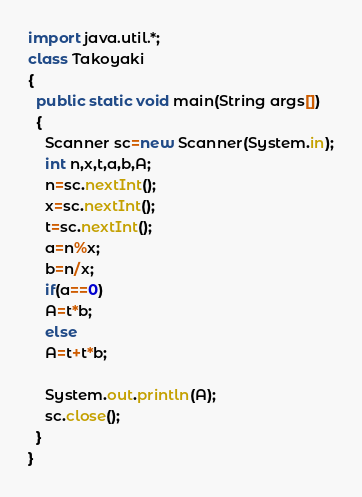Convert code to text. <code><loc_0><loc_0><loc_500><loc_500><_Java_>import java.util.*;
class Takoyaki
{
  public static void main(String args[])
  {
    Scanner sc=new Scanner(System.in);
    int n,x,t,a,b,A;
    n=sc.nextInt();
    x=sc.nextInt();
    t=sc.nextInt();
    a=n%x;
    b=n/x;
    if(a==0)
    A=t*b;
    else
    A=t+t*b;
    
    System.out.println(A);
    sc.close();
  }
}</code> 